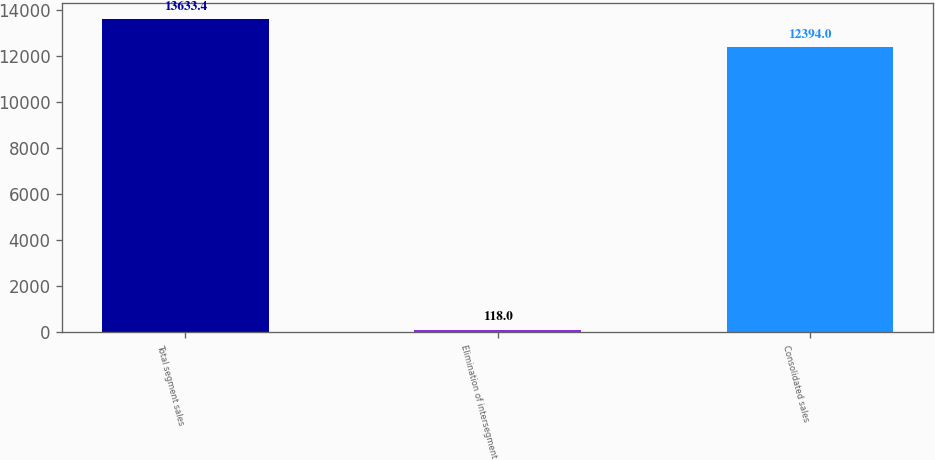<chart> <loc_0><loc_0><loc_500><loc_500><bar_chart><fcel>Total segment sales<fcel>Elimination of intersegment<fcel>Consolidated sales<nl><fcel>13633.4<fcel>118<fcel>12394<nl></chart> 